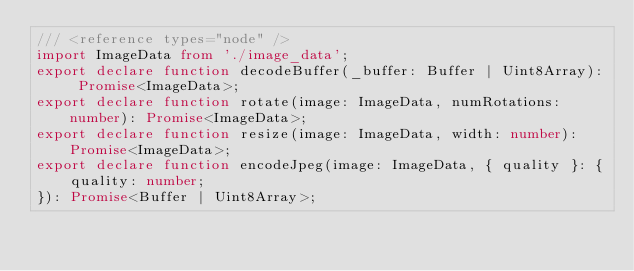<code> <loc_0><loc_0><loc_500><loc_500><_TypeScript_>/// <reference types="node" />
import ImageData from './image_data';
export declare function decodeBuffer(_buffer: Buffer | Uint8Array): Promise<ImageData>;
export declare function rotate(image: ImageData, numRotations: number): Promise<ImageData>;
export declare function resize(image: ImageData, width: number): Promise<ImageData>;
export declare function encodeJpeg(image: ImageData, { quality }: {
    quality: number;
}): Promise<Buffer | Uint8Array>;</code> 